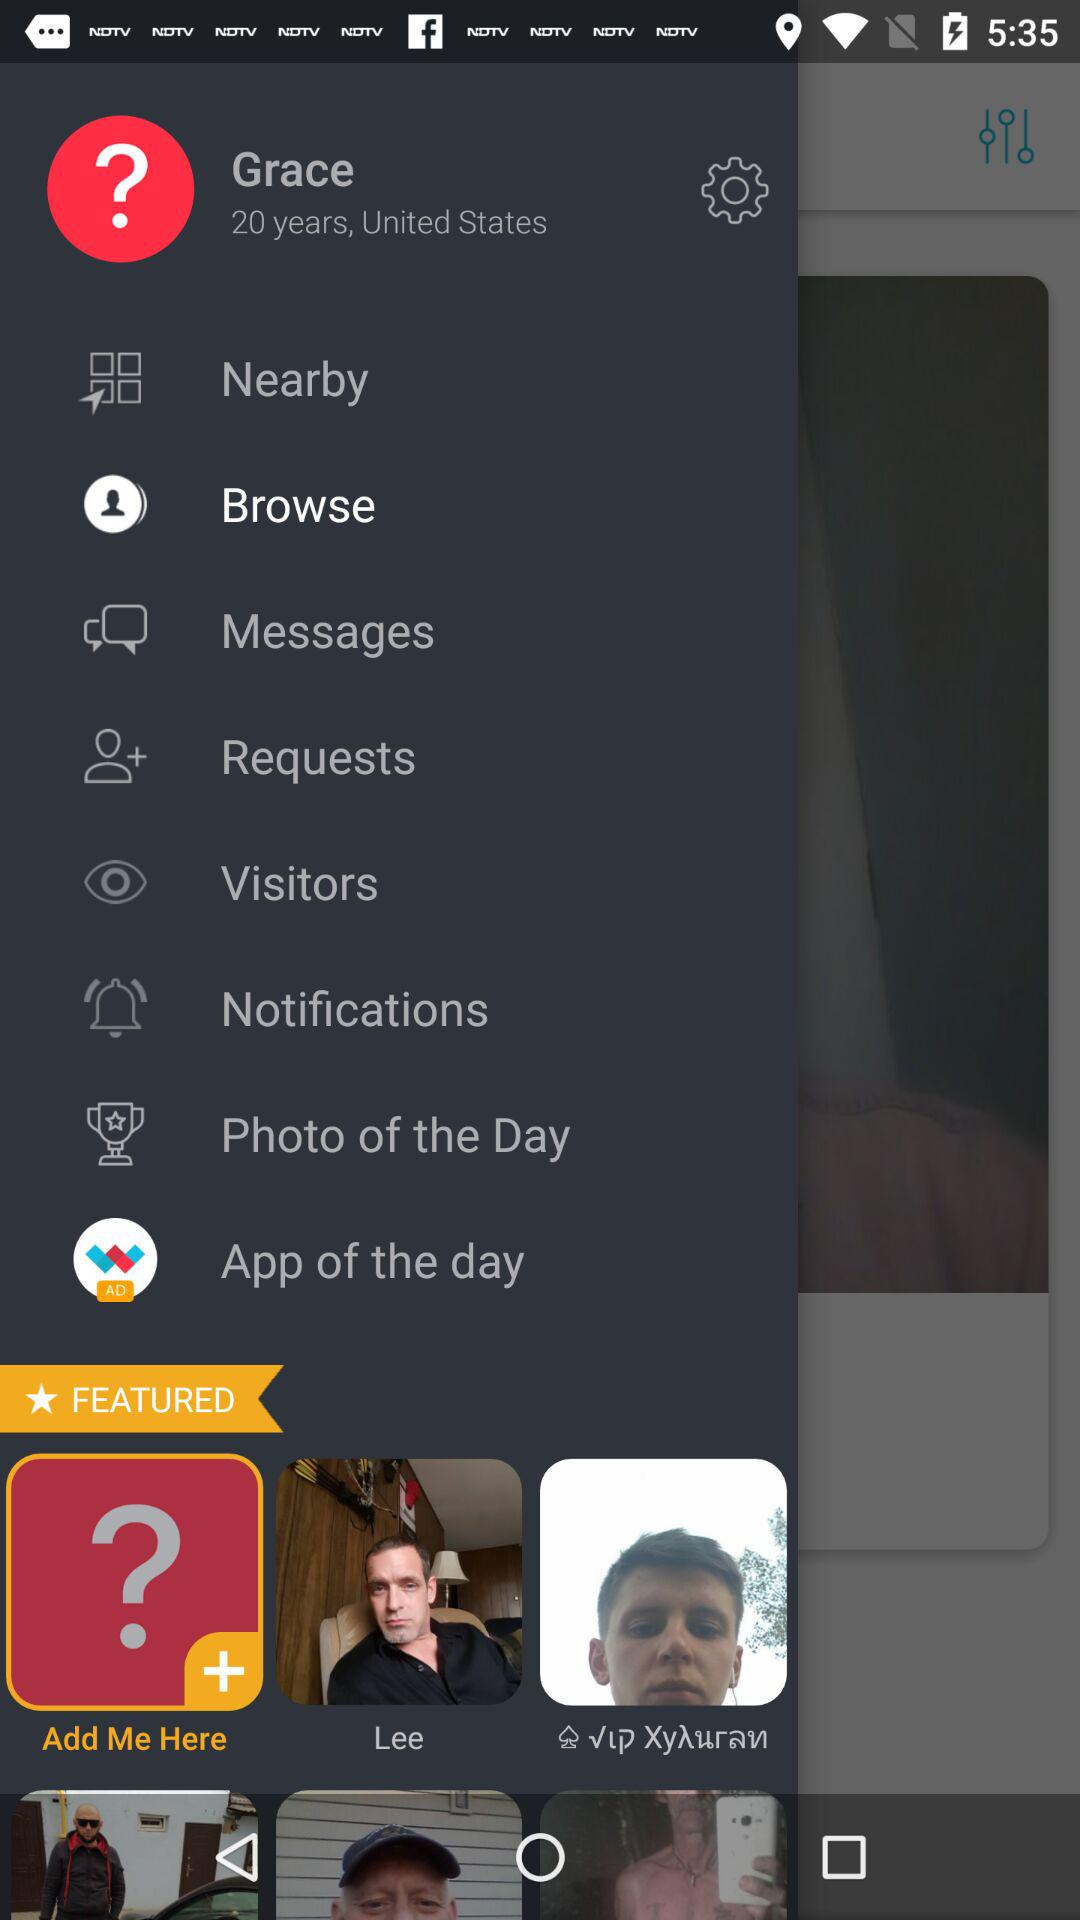Which is the selected option? The selected option is "Browse". 